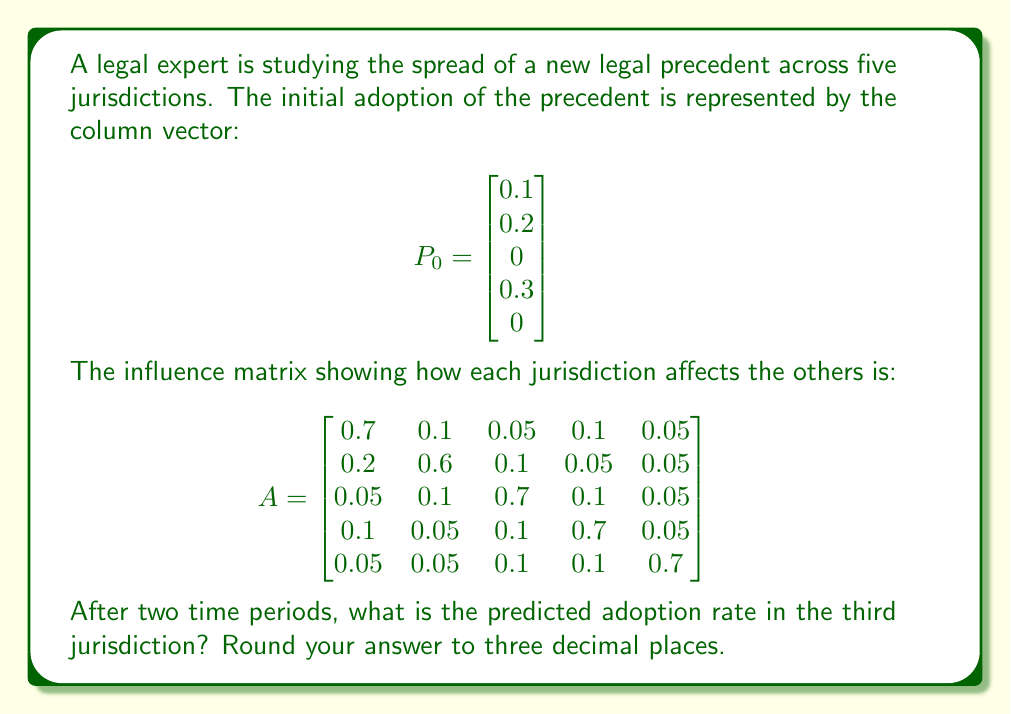What is the answer to this math problem? To solve this problem, we need to use matrix multiplication to model the spread of the legal precedent over time. The process is as follows:

1) First, we calculate the adoption rates after one time period:
   $P_1 = A \times P_0$

2) Then, we calculate the adoption rates after two time periods:
   $P_2 = A \times P_1 = A \times (A \times P_0) = A^2 \times P_0$

3) Let's perform these calculations step by step:

   $P_1 = A \times P_0 = \begin{bmatrix} 
   0.7 & 0.1 & 0.05 & 0.1 & 0.05 \\
   0.2 & 0.6 & 0.1 & 0.05 & 0.05 \\
   0.05 & 0.1 & 0.7 & 0.1 & 0.05 \\
   0.1 & 0.05 & 0.1 & 0.7 & 0.05 \\
   0.05 & 0.05 & 0.1 & 0.1 & 0.7
   \end{bmatrix} \times \begin{bmatrix} 0.1 \\ 0.2 \\ 0 \\ 0.3 \\ 0 \end{bmatrix}$

   $P_1 = \begin{bmatrix} 0.13 \\ 0.19 \\ 0.055 \\ 0.24 \\ 0.045 \end{bmatrix}$

4) Now, we calculate $P_2$:

   $P_2 = A \times P_1 = \begin{bmatrix} 
   0.7 & 0.1 & 0.05 & 0.1 & 0.05 \\
   0.2 & 0.6 & 0.1 & 0.05 & 0.05 \\
   0.05 & 0.1 & 0.7 & 0.1 & 0.05 \\
   0.1 & 0.05 & 0.1 & 0.7 & 0.05 \\
   0.05 & 0.05 & 0.1 & 0.1 & 0.7
   \end{bmatrix} \times \begin{bmatrix} 0.13 \\ 0.19 \\ 0.055 \\ 0.24 \\ 0.045 \end{bmatrix}$

   $P_2 = \begin{bmatrix} 0.1435 \\ 0.1865 \\ 0.1033 \\ 0.2218 \\ 0.0878 \end{bmatrix}$

5) The adoption rate in the third jurisdiction after two time periods is the third element of $P_2$, which is 0.1033.

6) Rounding to three decimal places, we get 0.103.
Answer: 0.103 